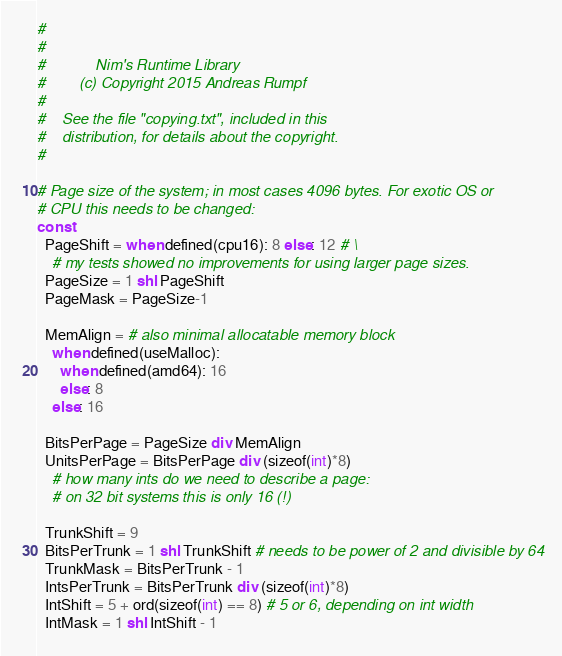Convert code to text. <code><loc_0><loc_0><loc_500><loc_500><_Nim_>#
#
#            Nim's Runtime Library
#        (c) Copyright 2015 Andreas Rumpf
#
#    See the file "copying.txt", included in this
#    distribution, for details about the copyright.
#

# Page size of the system; in most cases 4096 bytes. For exotic OS or
# CPU this needs to be changed:
const
  PageShift = when defined(cpu16): 8 else: 12 # \
    # my tests showed no improvements for using larger page sizes.
  PageSize = 1 shl PageShift
  PageMask = PageSize-1

  MemAlign = # also minimal allocatable memory block
    when defined(useMalloc):
      when defined(amd64): 16 
      else: 8
    else: 16

  BitsPerPage = PageSize div MemAlign
  UnitsPerPage = BitsPerPage div (sizeof(int)*8)
    # how many ints do we need to describe a page:
    # on 32 bit systems this is only 16 (!)

  TrunkShift = 9
  BitsPerTrunk = 1 shl TrunkShift # needs to be power of 2 and divisible by 64
  TrunkMask = BitsPerTrunk - 1
  IntsPerTrunk = BitsPerTrunk div (sizeof(int)*8)
  IntShift = 5 + ord(sizeof(int) == 8) # 5 or 6, depending on int width
  IntMask = 1 shl IntShift - 1
</code> 